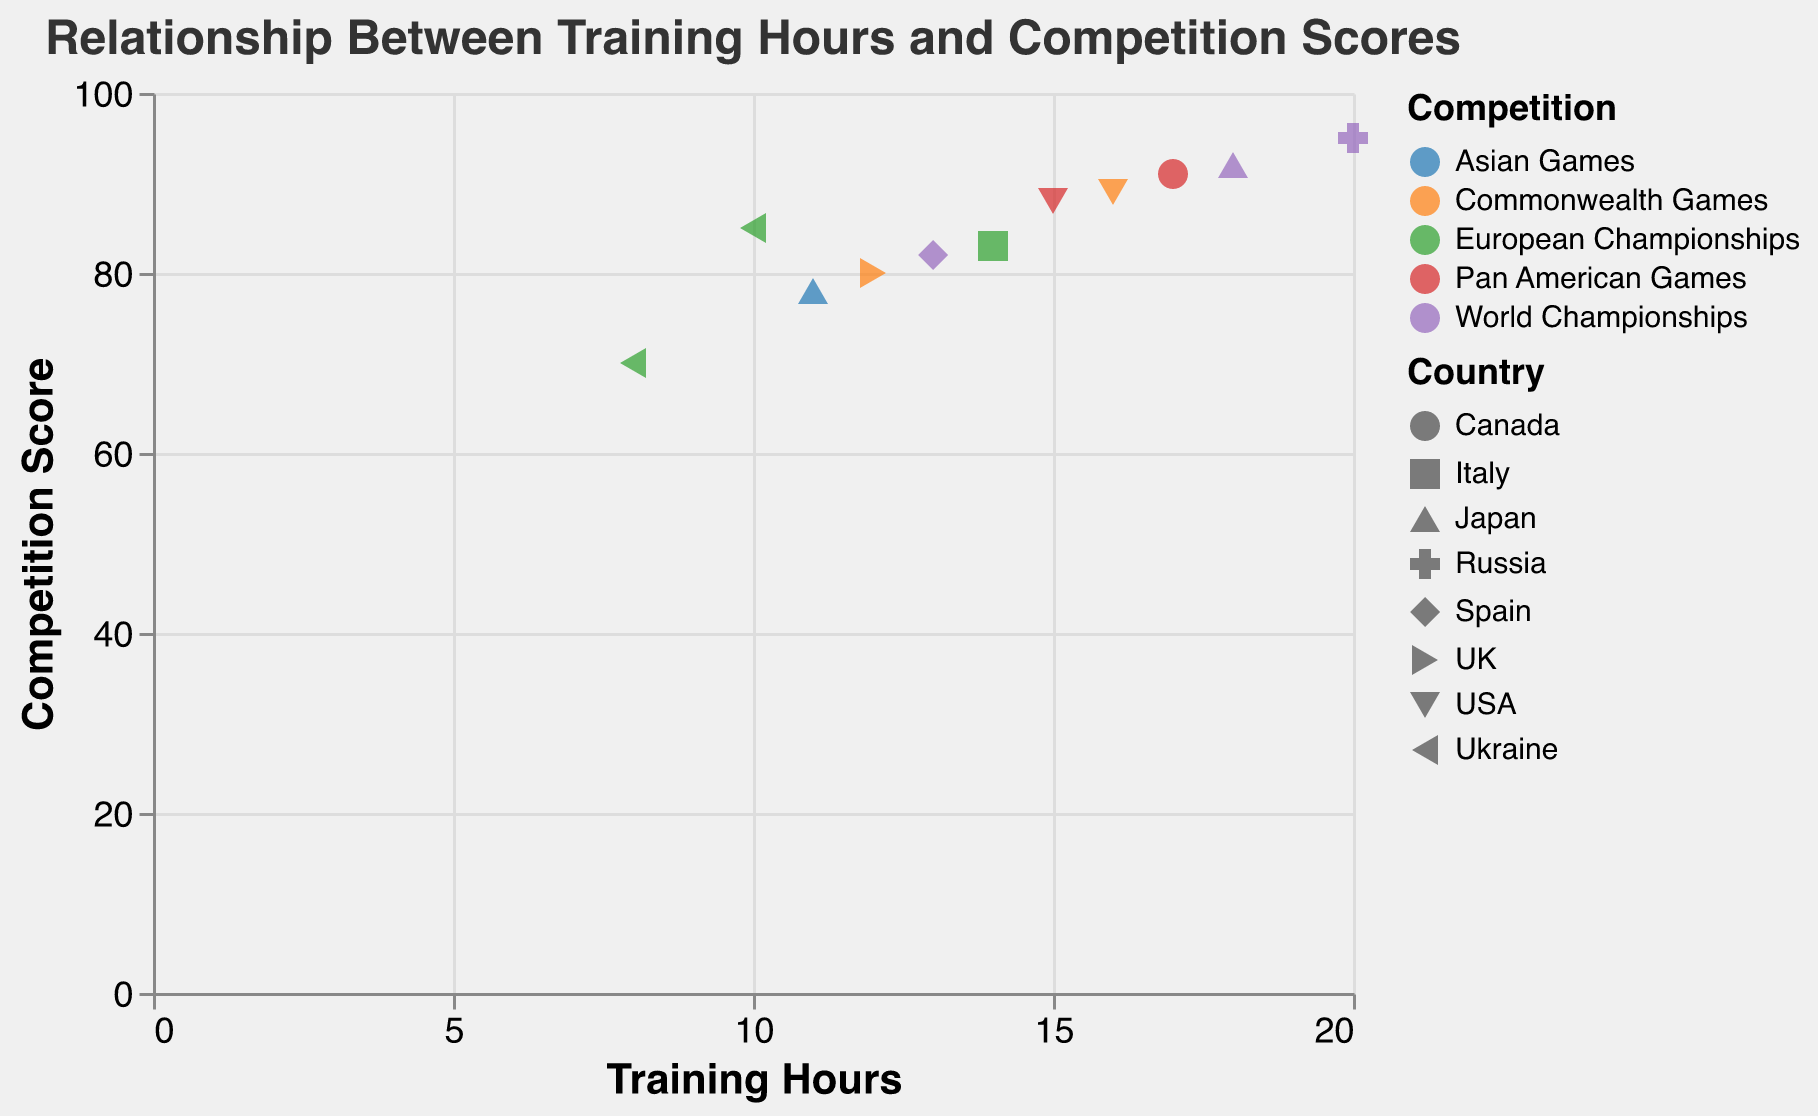How many data points are there on the scatter plot? Count each point displayed on the scatter plot. Each point represents a swimmer's data.
Answer: 11 Which country has the highest competition score represented on the plot? Identify the point with the highest y-axis value, then look at the corresponding "Country" attribute.
Answer: Russia What is the relationship between training hours and competition scores as shown in the title? The plot's title explicitly states the nature of the relationship it is visualizing.
Answer: Relationship Between Training Hours and Competition Scores Who is the swimmer with the lowest competition score and how many hours did they train? Find the point with the lowest y-axis value, then check its corresponding tooltip information.
Answer: Anna Voloshyna, 8 hours What is the average training hours of the swimmers from Ukraine? Identify the points representing Ukrainian swimmers and average their training hours: (10 + 8) / 2 = 9.
Answer: 9 hours Which competition has the most varied competition scores based on the color categories? Observe the spread of points within each color category; the "World Championships" has the highest range from 82 to 95.
Answer: World Championships Who are the top two swimmers with the highest competition scores and what are their scores? Identify the two highest points on the y-axis and check their corresponding tooltip information.
Answer: Svetlana Kolesnichenko (95) and Yukiko Inui (92) Which swimmer has approximately the middlemost training hours and what is their competition score? Arrange the swimmers by their training hours, find the median training hours (the 6th value), and note the competition score.
Answer: Linda Cerruti, 83 Are there any competitions where multiple swimmers have the same competition score? Look at the y-axis values and compare them within each distinct color group. None of the competitions have overlapping scores.
Answer: No How many different countries are represented by unique shapes on the plot? Count the unique shapes as each shape represents a different country according to the legend.
Answer: 8 